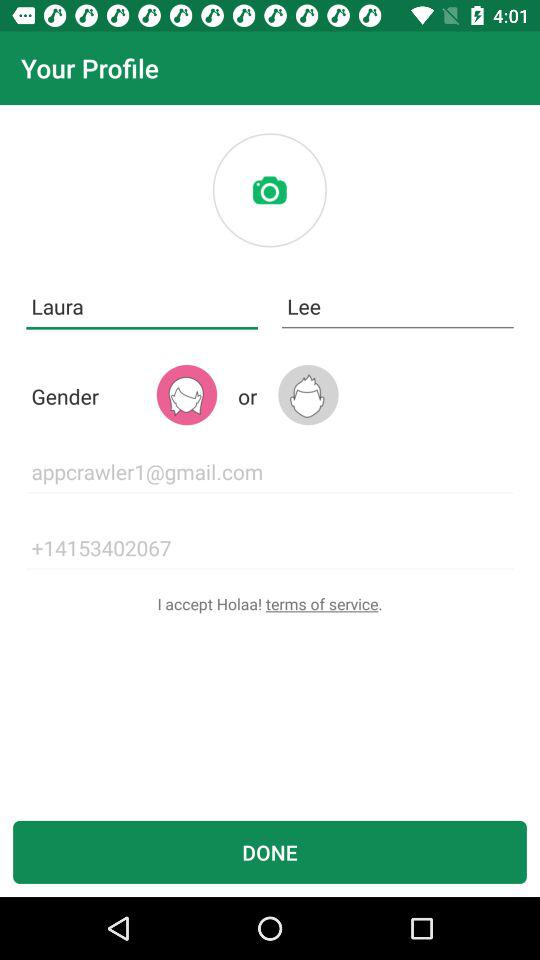What is the user's last name? The user's last name is Lee. 